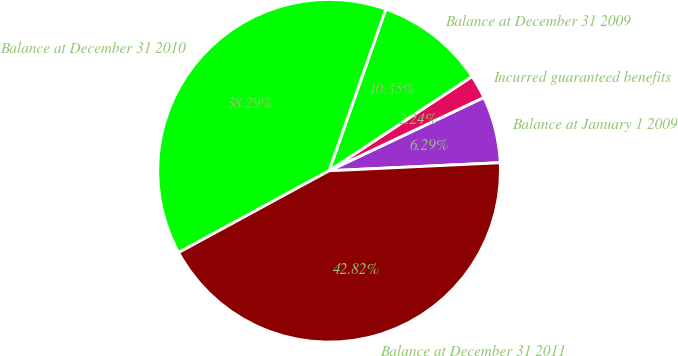Convert chart to OTSL. <chart><loc_0><loc_0><loc_500><loc_500><pie_chart><fcel>Balance at January 1 2009<fcel>Incurred guaranteed benefits<fcel>Balance at December 31 2009<fcel>Balance at December 31 2010<fcel>Balance at December 31 2011<nl><fcel>6.29%<fcel>2.24%<fcel>10.35%<fcel>38.29%<fcel>42.82%<nl></chart> 